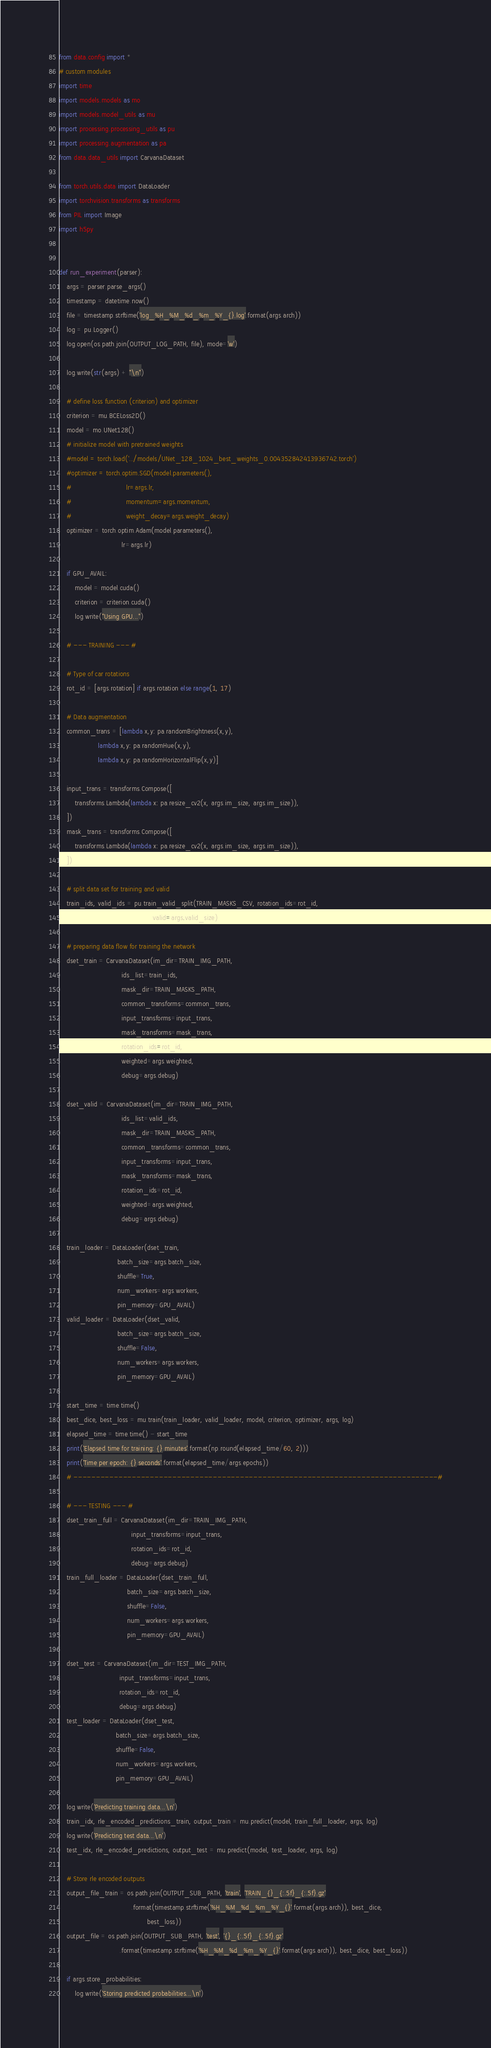Convert code to text. <code><loc_0><loc_0><loc_500><loc_500><_Python_>from data.config import *
# custom modules
import time
import models.models as mo
import models.model_utils as mu
import processing.processing_utils as pu
import processing.augmentation as pa
from data.data_utils import CarvanaDataset

from torch.utils.data import DataLoader
import torchvision.transforms as transforms
from PIL import Image
import h5py


def run_experiment(parser):
    args = parser.parse_args()
    timestamp = datetime.now()
    file = timestamp.strftime('log_%H_%M_%d_%m_%Y_{}.log'.format(args.arch))
    log = pu.Logger()
    log.open(os.path.join(OUTPUT_LOG_PATH, file), mode='w')

    log.write(str(args) + "\n")

    # define loss function (criterion) and optimizer
    criterion = mu.BCELoss2D()
    model = mo.UNet128()
    # initialize model with pretrained weights
    #model = torch.load('../models/UNet_128_1024_best_weights_0.004352842413936742.torch')
    #optimizer = torch.optim.SGD(model.parameters(),
    #                            lr=args.lr,
    #                            momentum=args.momentum,
    #                            weight_decay=args.weight_decay)
    optimizer = torch.optim.Adam(model.parameters(),
                                lr=args.lr)

    if GPU_AVAIL:
        model = model.cuda()
        criterion = criterion.cuda()
        log.write("Using GPU...")

    # --- TRAINING --- #

    # Type of car rotations
    rot_id = [args.rotation] if args.rotation else range(1, 17)

    # Data augmentation
    common_trans = [lambda x,y: pa.randomBrightness(x,y),
                    lambda x,y: pa.randomHue(x,y),
                    lambda x,y: pa.randomHorizontalFlip(x,y)]

    input_trans = transforms.Compose([
        transforms.Lambda(lambda x: pa.resize_cv2(x, args.im_size, args.im_size)),
    ])
    mask_trans = transforms.Compose([
        transforms.Lambda(lambda x: pa.resize_cv2(x, args.im_size, args.im_size)),
    ])

    # split data set for training and valid
    train_ids, valid_ids = pu.train_valid_split(TRAIN_MASKS_CSV, rotation_ids=rot_id,
                                                valid=args.valid_size)

    # preparing data flow for training the network
    dset_train = CarvanaDataset(im_dir=TRAIN_IMG_PATH,
                                ids_list=train_ids,
                                mask_dir=TRAIN_MASKS_PATH,
                                common_transforms=common_trans,
                                input_transforms=input_trans,
                                mask_transforms=mask_trans,
                                rotation_ids=rot_id,
                                weighted=args.weighted,
                                debug=args.debug)

    dset_valid = CarvanaDataset(im_dir=TRAIN_IMG_PATH,
                                ids_list=valid_ids,
                                mask_dir=TRAIN_MASKS_PATH,
                                common_transforms=common_trans,
                                input_transforms=input_trans,
                                mask_transforms=mask_trans,
                                rotation_ids=rot_id,
                                weighted=args.weighted,
                                debug=args.debug)

    train_loader = DataLoader(dset_train,
                              batch_size=args.batch_size,
                              shuffle=True,
                              num_workers=args.workers,
                              pin_memory=GPU_AVAIL)
    valid_loader = DataLoader(dset_valid,
                              batch_size=args.batch_size,
                              shuffle=False,
                              num_workers=args.workers,
                              pin_memory=GPU_AVAIL)

    start_time = time.time()
    best_dice, best_loss = mu.train(train_loader, valid_loader, model, criterion, optimizer, args, log)
    elapsed_time = time.time() - start_time
    print('Elapsed time for training: {} minutes'.format(np.round(elapsed_time/60, 2)))
    print('Time per epoch: {} seconds'.format(elapsed_time/args.epochs))
    # ---------------------------------------------------------------------------------#

    # --- TESTING --- #
    dset_train_full = CarvanaDataset(im_dir=TRAIN_IMG_PATH,
                                     input_transforms=input_trans,
                                     rotation_ids=rot_id,
                                     debug=args.debug)
    train_full_loader = DataLoader(dset_train_full,
                                   batch_size=args.batch_size,
                                   shuffle=False,
                                   num_workers=args.workers,
                                   pin_memory=GPU_AVAIL)

    dset_test = CarvanaDataset(im_dir=TEST_IMG_PATH,
                               input_transforms=input_trans,
                               rotation_ids=rot_id,
                               debug=args.debug)
    test_loader = DataLoader(dset_test,
                             batch_size=args.batch_size,
                             shuffle=False,
                             num_workers=args.workers,
                             pin_memory=GPU_AVAIL)

    log.write('Predicting training data...\n')
    train_idx, rle_encoded_predictions_train, output_train = mu.predict(model, train_full_loader, args, log)
    log.write('Predicting test data...\n')
    test_idx, rle_encoded_predictions, output_test = mu.predict(model, test_loader, args, log)

    # Store rle encoded outputs
    output_file_train = os.path.join(OUTPUT_SUB_PATH, 'train', 'TRAIN_{}_{:.5f}_{:.5f}.gz'
                                     .format(timestamp.strftime('%H_%M_%d_%m_%Y_{}'.format(args.arch)), best_dice,
                                             best_loss))
    output_file = os.path.join(OUTPUT_SUB_PATH, 'test', '{}_{:.5f}_{:.5f}.gz'
                               .format(timestamp.strftime('%H_%M_%d_%m_%Y_{}'.format(args.arch)), best_dice, best_loss))

    if args.store_probabilities:
        log.write('Storing predicted probabilities...\n')</code> 